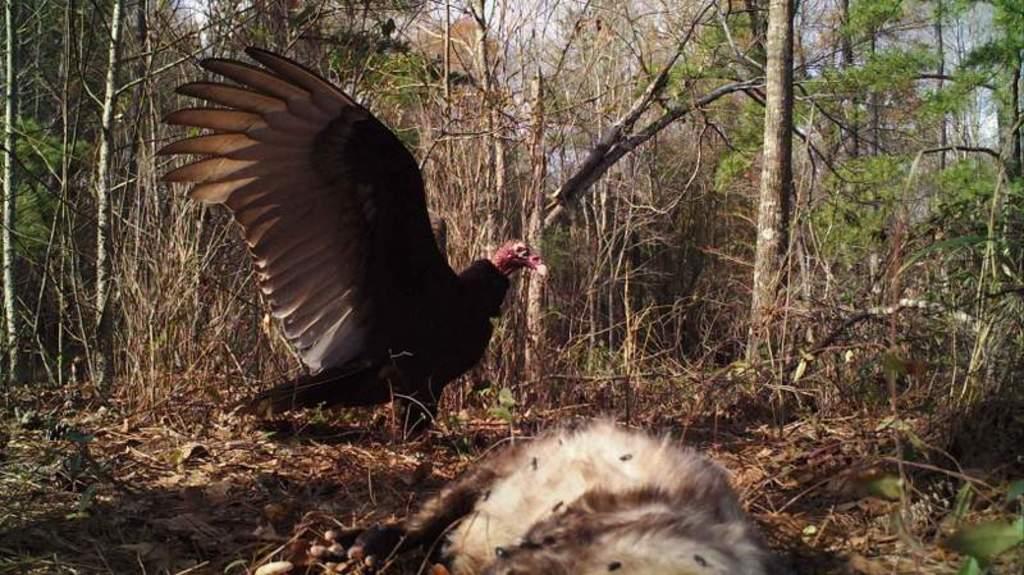How would you summarize this image in a sentence or two? In this image I can see a bird which is in brown color. Background I can see trees in green color and sky in white color. 